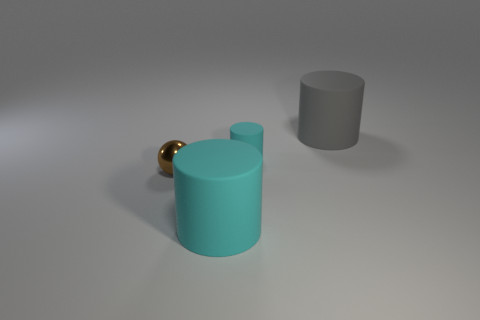Subtract all cyan matte cylinders. How many cylinders are left? 1 Add 2 metal objects. How many objects exist? 6 Subtract all gray cylinders. How many cylinders are left? 2 Subtract all cylinders. How many objects are left? 1 Subtract all yellow metallic things. Subtract all shiny objects. How many objects are left? 3 Add 1 small brown metallic things. How many small brown metallic things are left? 2 Add 4 big cyan matte cylinders. How many big cyan matte cylinders exist? 5 Subtract 0 brown cylinders. How many objects are left? 4 Subtract all yellow cylinders. Subtract all cyan blocks. How many cylinders are left? 3 Subtract all purple cubes. How many purple cylinders are left? 0 